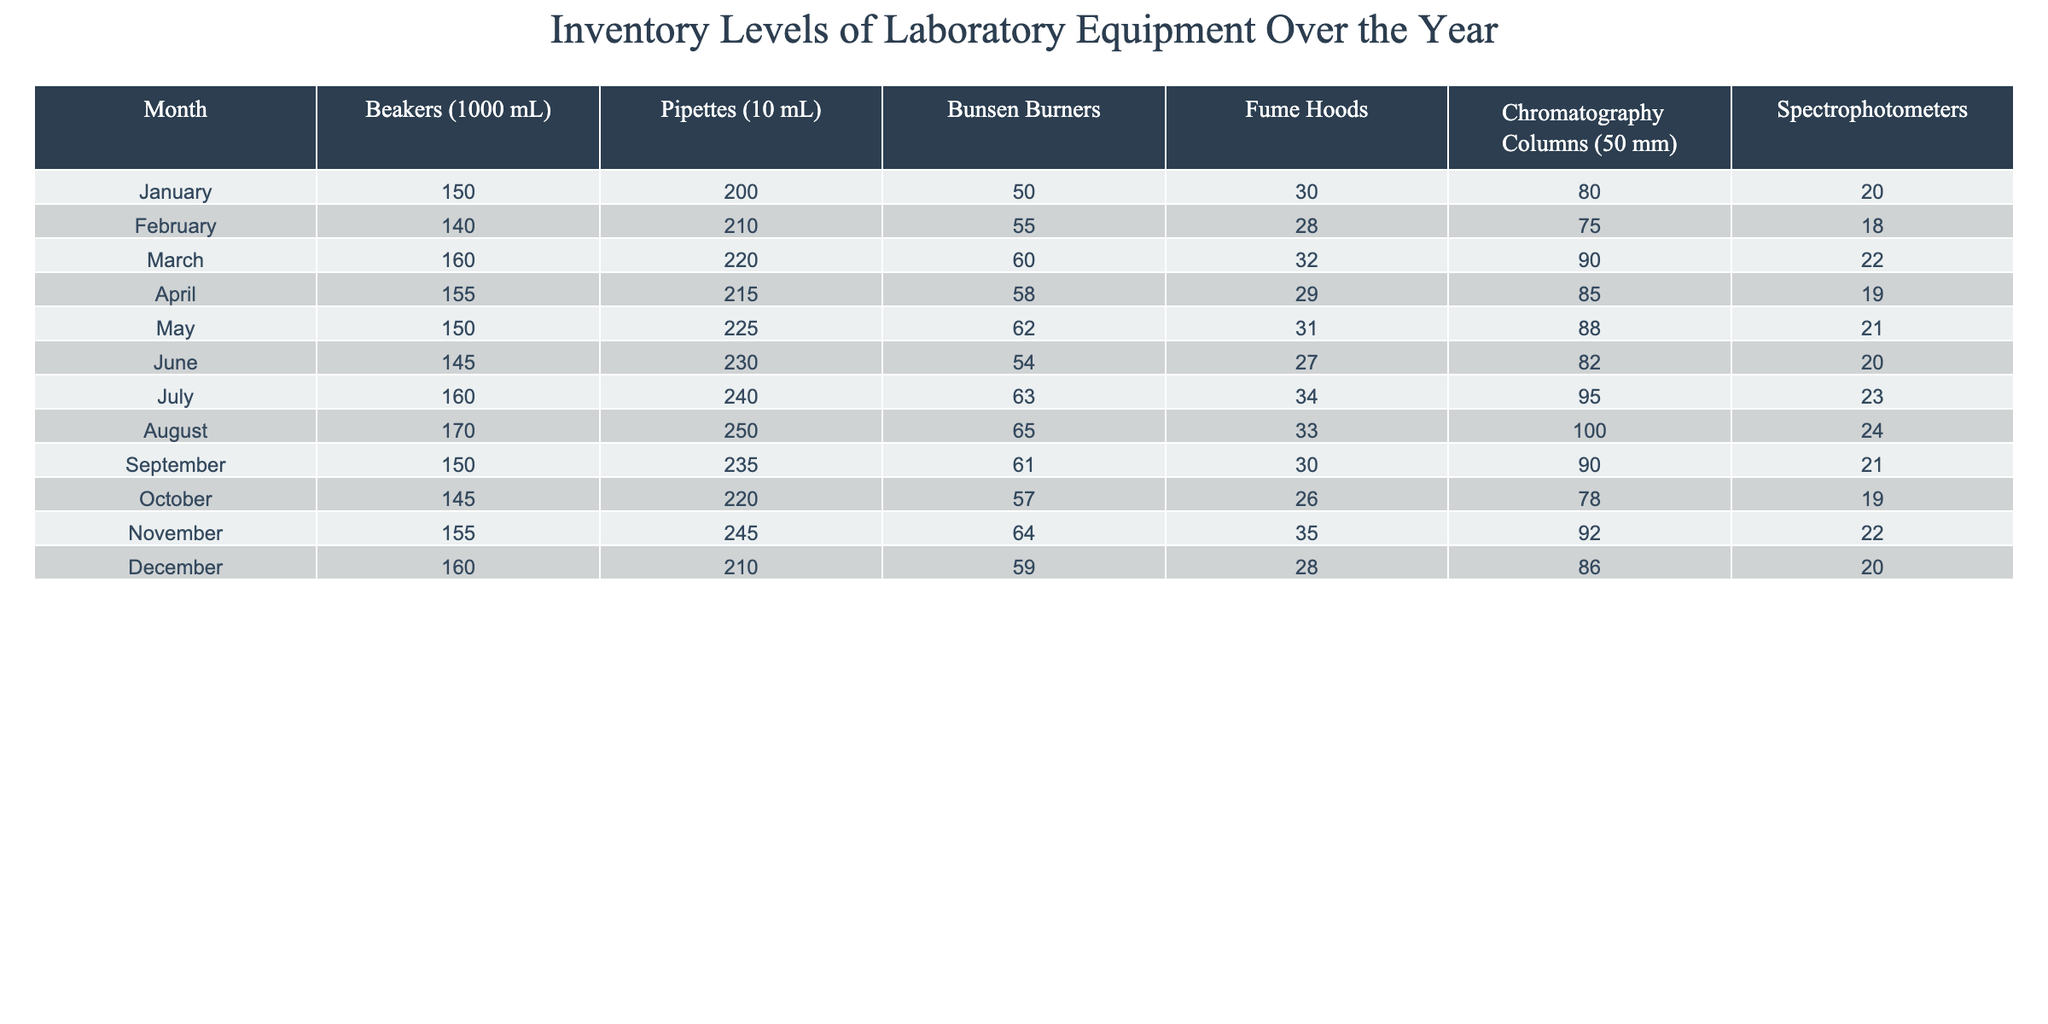What is the highest number of pipettes recorded in a single month? The maximum value of pipettes across all months is found by comparing each monthly total. The highest value appears in August with 250 pipettes.
Answer: 250 Which month had the lowest inventory of fume hoods? By evaluating the fume hood values for each month, the lowest value is seen in October, which has 26 fume hoods.
Answer: October What was the average number of beakers over the year? To find the average, sum the beaker values across all months: (150 + 140 + 160 + 155 + 150 + 145 + 160 + 170 + 150 + 145 + 155 + 160) = 1825. Divide by 12 months gives 1825/12 = approximately 152.08, which rounds down to 152.
Answer: 152 Which piece of equipment had a consistent increase in inventory from January to August? Evaluating the monthly inventory of each piece of equipment, both pipettes and Bunsen burners consistently increased from January to August.
Answer: Pipettes and Bunsen Burners How many more chromatography columns were there in July compared to December? The number of chromatography columns in July is 95 and in December is 86. The difference is 95 - 86 = 9.
Answer: 9 Which month has the second-highest number of spectrophotometers? The spectrophotometer values list for all months is checked. The highest is in August (24), and the second-highest is in November (22).
Answer: November What is the total inventory of fume hoods over the entire year? Sum the values for each month: (30 + 28 + 32 + 29 + 31 + 27 + 34 + 33 + 30 + 26 + 35 + 28) =  367.
Answer: 367 Did the number of beakers increase in August compared to January? Compare the beaker values from January (150) and August (170). The value in August is higher, indicating an increase.
Answer: Yes What is the median number of Bunsen burners throughout the year? The monthly values for Bunsen burners are sorted: 50, 55, 57, 58, 60, 61, 63, 64, 65. The middle value (median) of the sorted list (when there are 12 values) is the average of the 6th and 7th values, which are 61 and 63. Thus, (61 + 63)/2 = 62.
Answer: 62 In which month did the number of chromatography columns decrease compared to the previous month? Observing the month-to-month values for chromatography columns shows a decrease from July (95) to August (100). In August, the numbers resume increasing afterward.
Answer: July to August 